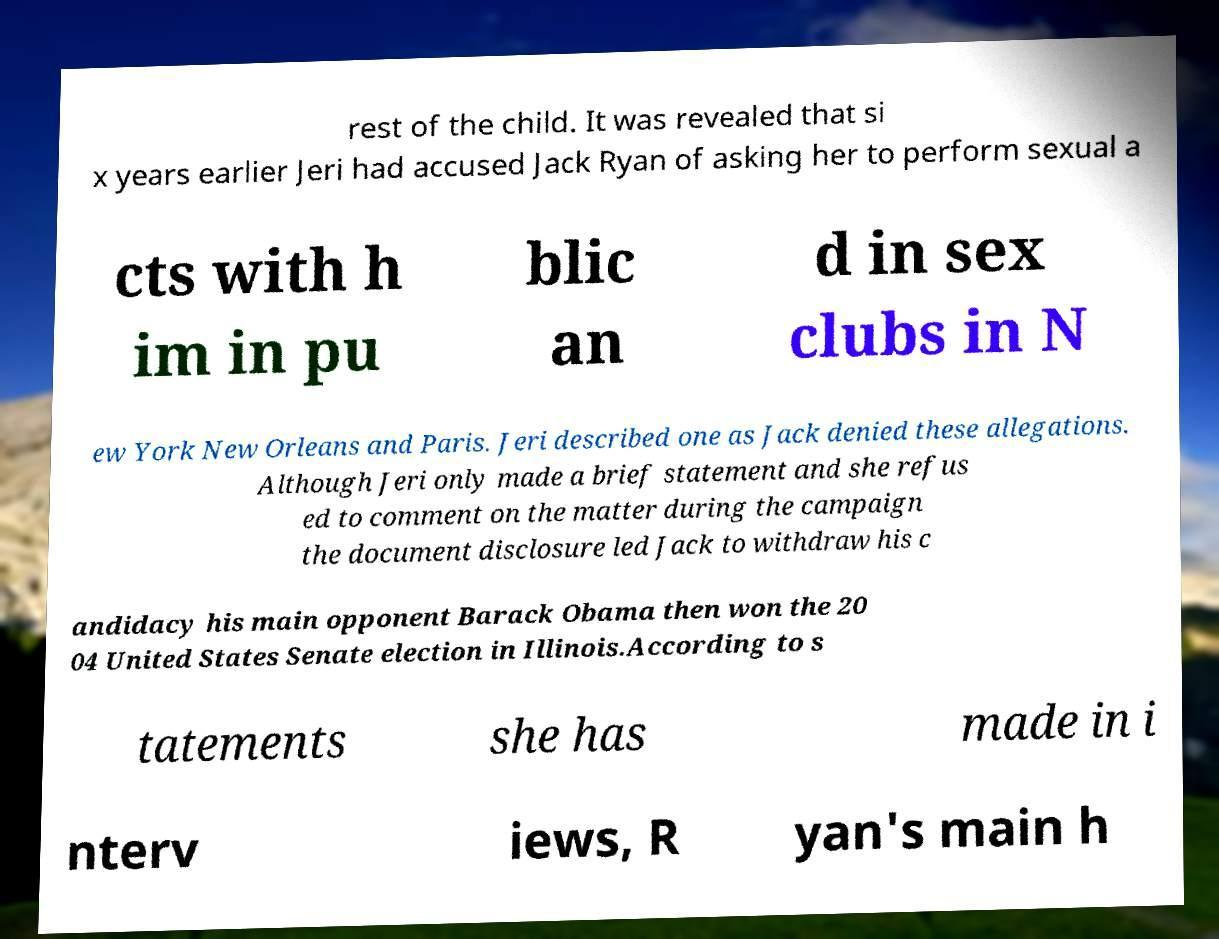Please read and relay the text visible in this image. What does it say? rest of the child. It was revealed that si x years earlier Jeri had accused Jack Ryan of asking her to perform sexual a cts with h im in pu blic an d in sex clubs in N ew York New Orleans and Paris. Jeri described one as Jack denied these allegations. Although Jeri only made a brief statement and she refus ed to comment on the matter during the campaign the document disclosure led Jack to withdraw his c andidacy his main opponent Barack Obama then won the 20 04 United States Senate election in Illinois.According to s tatements she has made in i nterv iews, R yan's main h 